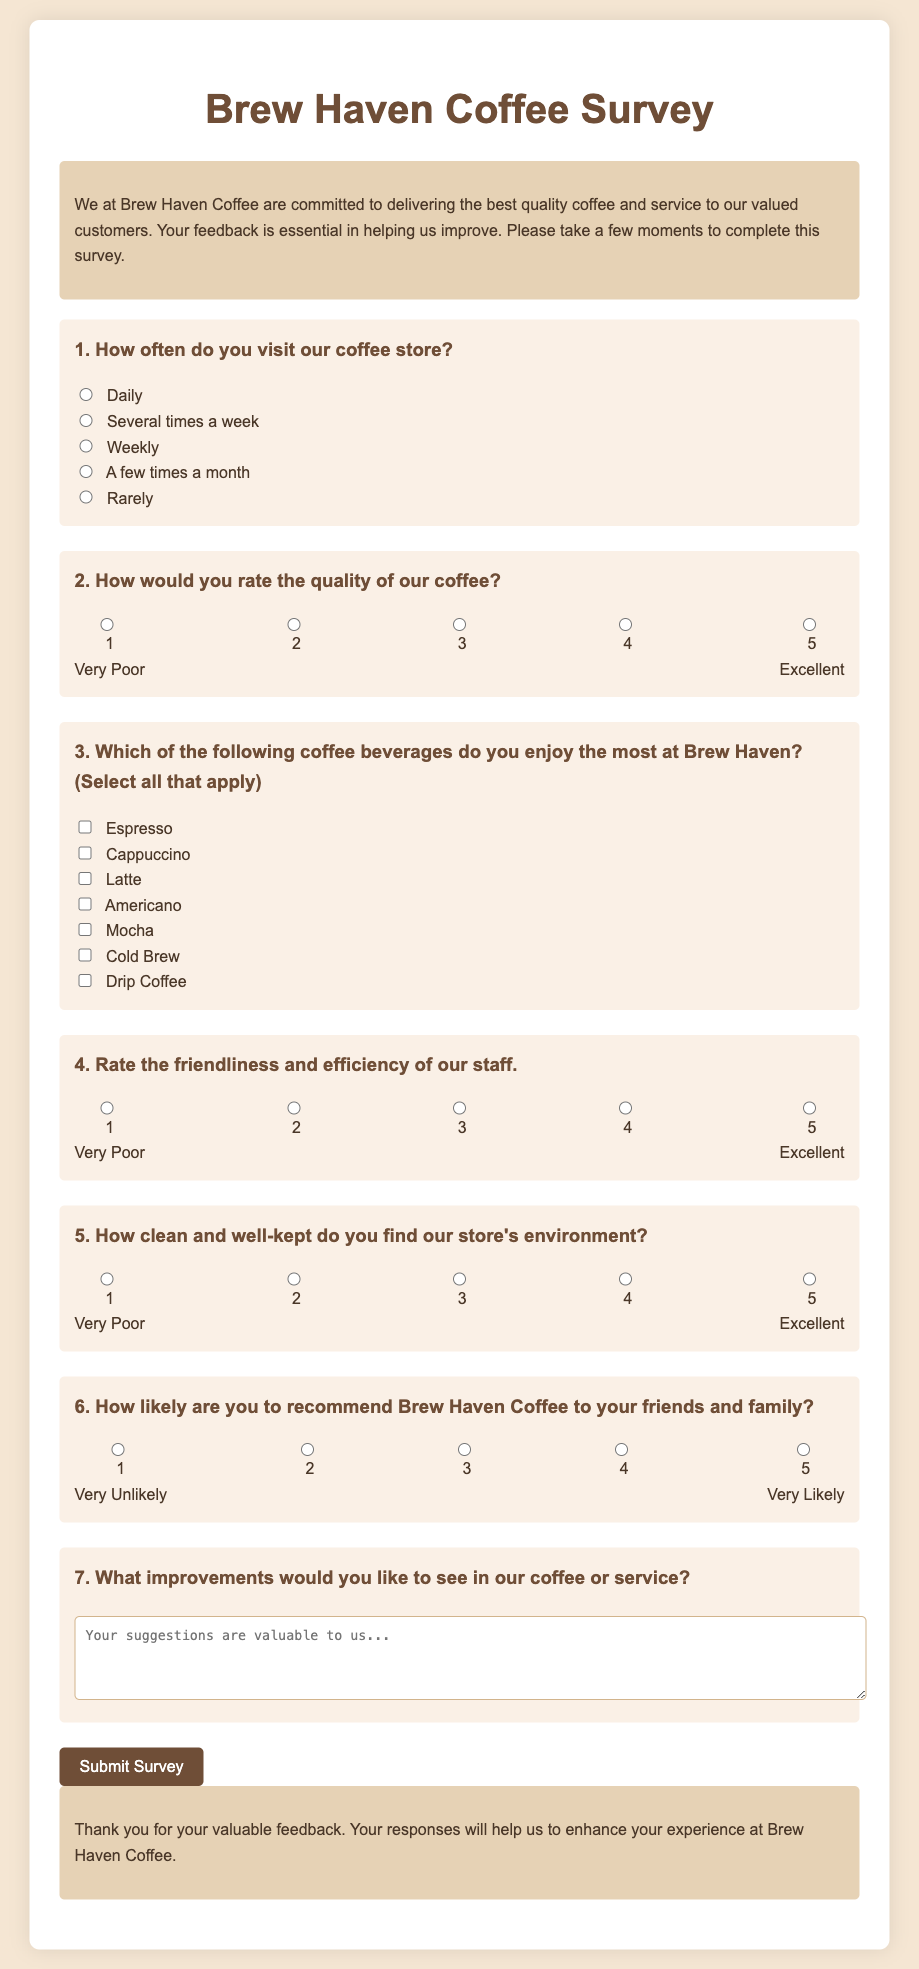What is the title of the survey? The title of the survey is displayed prominently at the top of the document.
Answer: Brew Haven Coffee Survey How many questions are included in the survey? The survey consists of a total of seven questions.
Answer: 7 What rating scale is used to assess coffee quality? The rating scale ranges from 1 to 5, with descriptors for each rating.
Answer: 1 to 5 What improvement suggestions are requested from customers? The document explicitly asks for customer suggestions to improve coffee or service.
Answer: Improvements How are the questions in the survey organized? The questions are organized in sections with titles and options for responses.
Answer: By question numbers What is the maximum word limit for suggestions in the textarea? The textarea allows customers to enter suggestions, but no specific limit is mentioned.
Answer: Not specified Which beverage option is NOT listed in the survey? The question tests knowledge of the beverage options provided in the form.
Answer: None (all options are listed) How likely are customers encouraged to recommend Brew Haven Coffee? The survey assesses customers' likelihood to recommend the coffee shop using a rating system.
Answer: Likelihood 